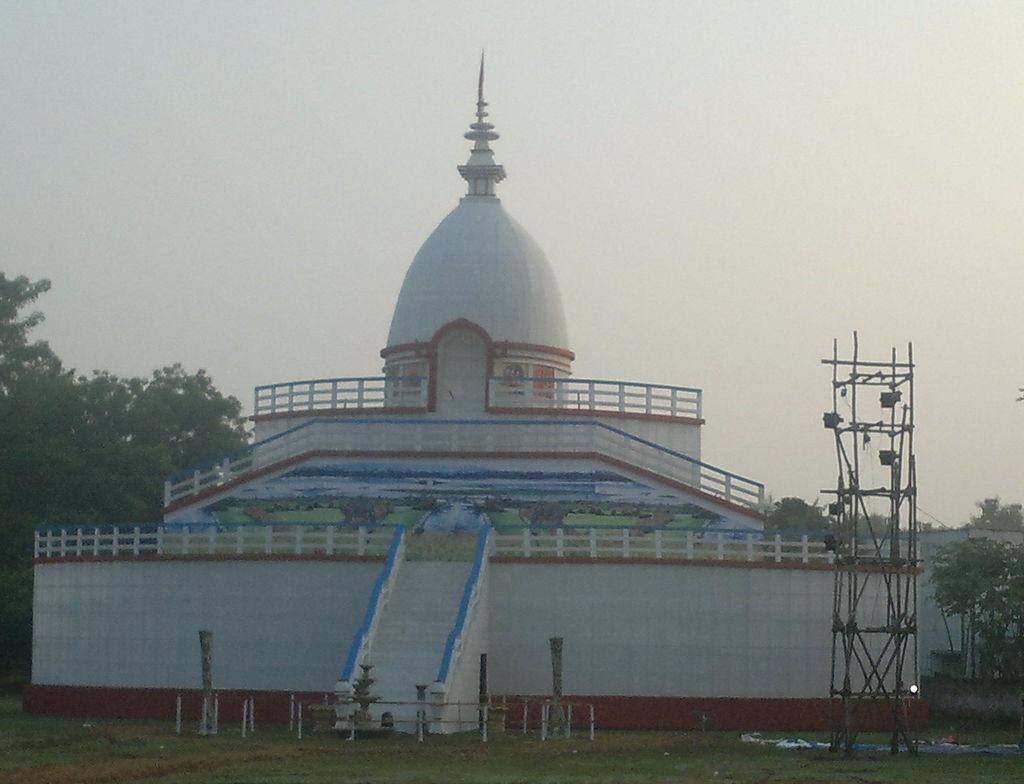How would you summarize this image in a sentence or two? In the image there is white building with a tomb above it with trees behind it and above its sky. 